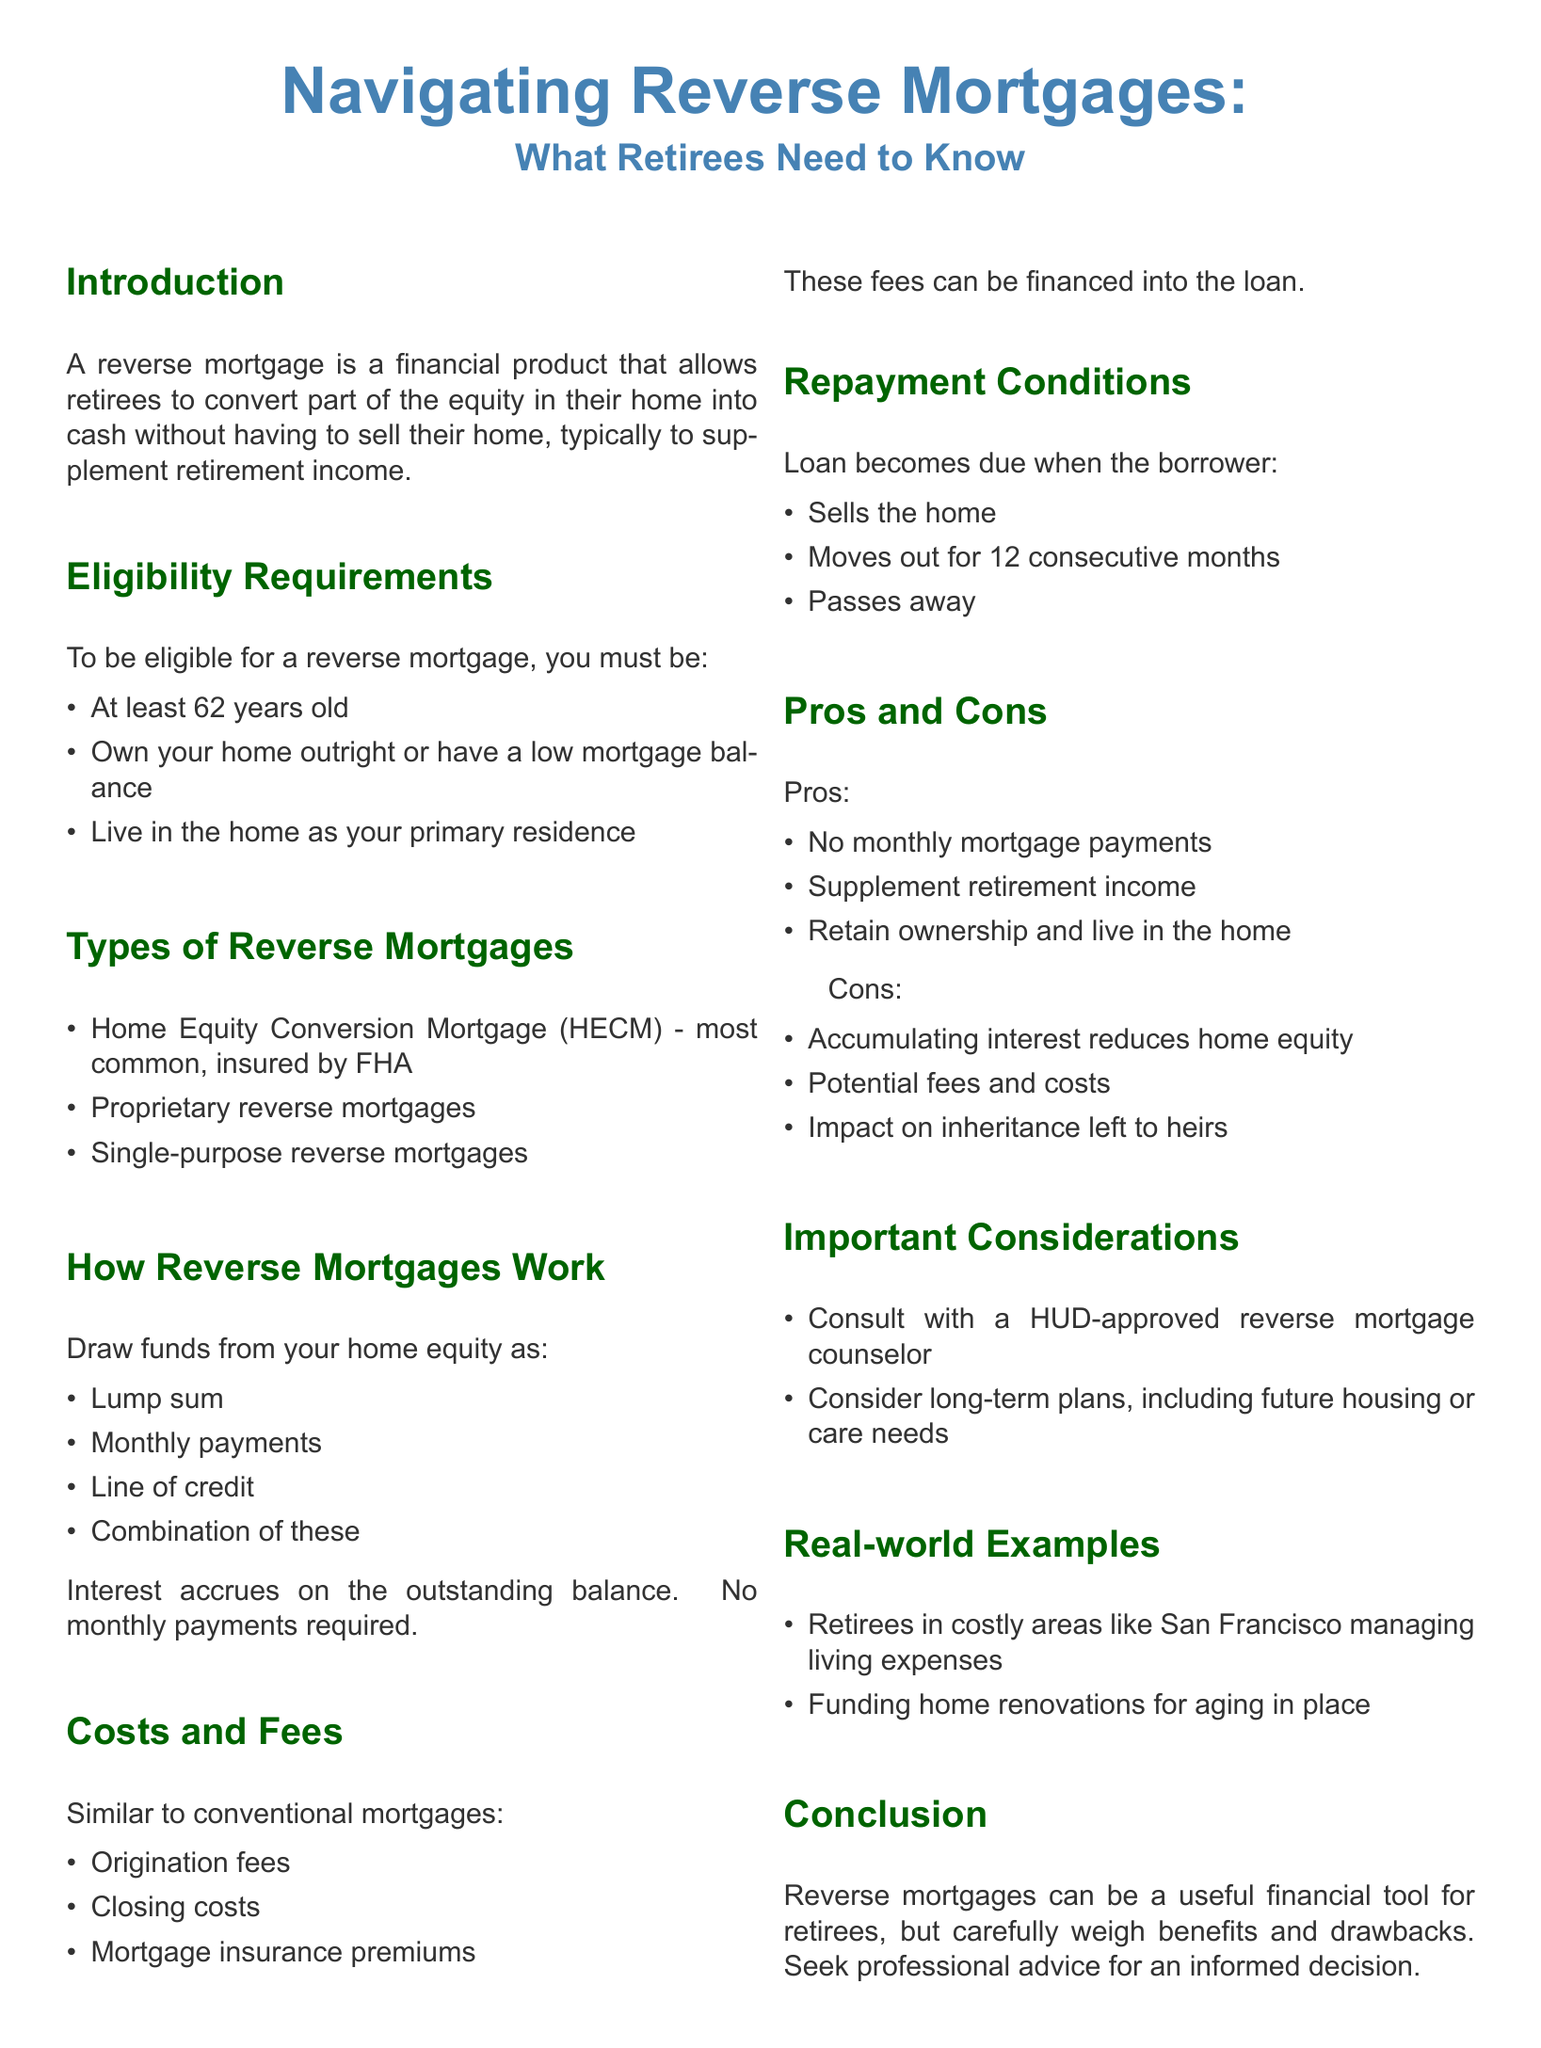What is a reverse mortgage? A reverse mortgage is a financial product that allows retirees to convert part of the equity in their home into cash without having to sell their home.
Answer: A financial product What is the minimum age for reverse mortgage eligibility? The eligibility requirements state that the borrower must be at least 62 years old.
Answer: 62 years old What type of reverse mortgage is most common? The document mentions that the Home Equity Conversion Mortgage (HECM) is the most common type of reverse mortgage, insured by FHA.
Answer: Home Equity Conversion Mortgage (HECM) What are three ways to draw funds from a reverse mortgage? The document lists several ways, three of which include lump sum, monthly payments, and line of credit.
Answer: Lump sum, monthly payments, line of credit What is a significant con of a reverse mortgage related to home equity? The document states that accumulating interest reduces home equity as a potential drawback.
Answer: Reduces home equity When does the loan become due? The document outlines that the loan becomes due when the borrower sells the home, moves out for 12 consecutive months, or passes away.
Answer: When the borrower sells the home How can fees and costs be managed? The guide mentions that similar to conventional mortgages, fees can be financed into the loan.
Answer: Financed into the loan What should retirees consult before proceeding with a reverse mortgage? It's recommended to consult with a HUD-approved reverse mortgage counselor before making decisions.
Answer: HUD-approved reverse mortgage counselor What is one real-world example of reverse mortgage use? The document provides an example of retirees in costly areas managing living expenses with a reverse mortgage.
Answer: Managing living expenses 